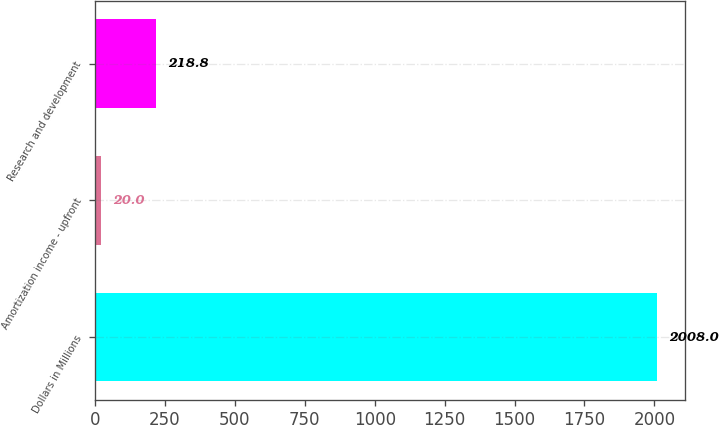Convert chart. <chart><loc_0><loc_0><loc_500><loc_500><bar_chart><fcel>Dollars in Millions<fcel>Amortization income - upfront<fcel>Research and development<nl><fcel>2008<fcel>20<fcel>218.8<nl></chart> 